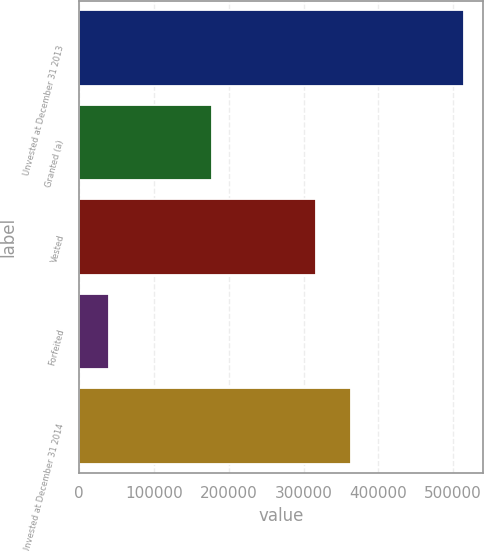Convert chart. <chart><loc_0><loc_0><loc_500><loc_500><bar_chart><fcel>Unvested at December 31 2013<fcel>Granted (a)<fcel>Vested<fcel>Forfeited<fcel>Unvested at December 31 2014<nl><fcel>514000<fcel>177000<fcel>316000<fcel>40000<fcel>363400<nl></chart> 